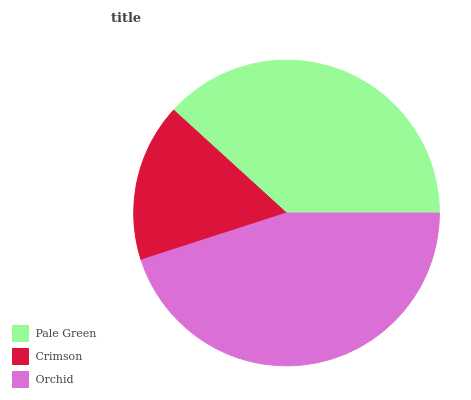Is Crimson the minimum?
Answer yes or no. Yes. Is Orchid the maximum?
Answer yes or no. Yes. Is Orchid the minimum?
Answer yes or no. No. Is Crimson the maximum?
Answer yes or no. No. Is Orchid greater than Crimson?
Answer yes or no. Yes. Is Crimson less than Orchid?
Answer yes or no. Yes. Is Crimson greater than Orchid?
Answer yes or no. No. Is Orchid less than Crimson?
Answer yes or no. No. Is Pale Green the high median?
Answer yes or no. Yes. Is Pale Green the low median?
Answer yes or no. Yes. Is Crimson the high median?
Answer yes or no. No. Is Orchid the low median?
Answer yes or no. No. 